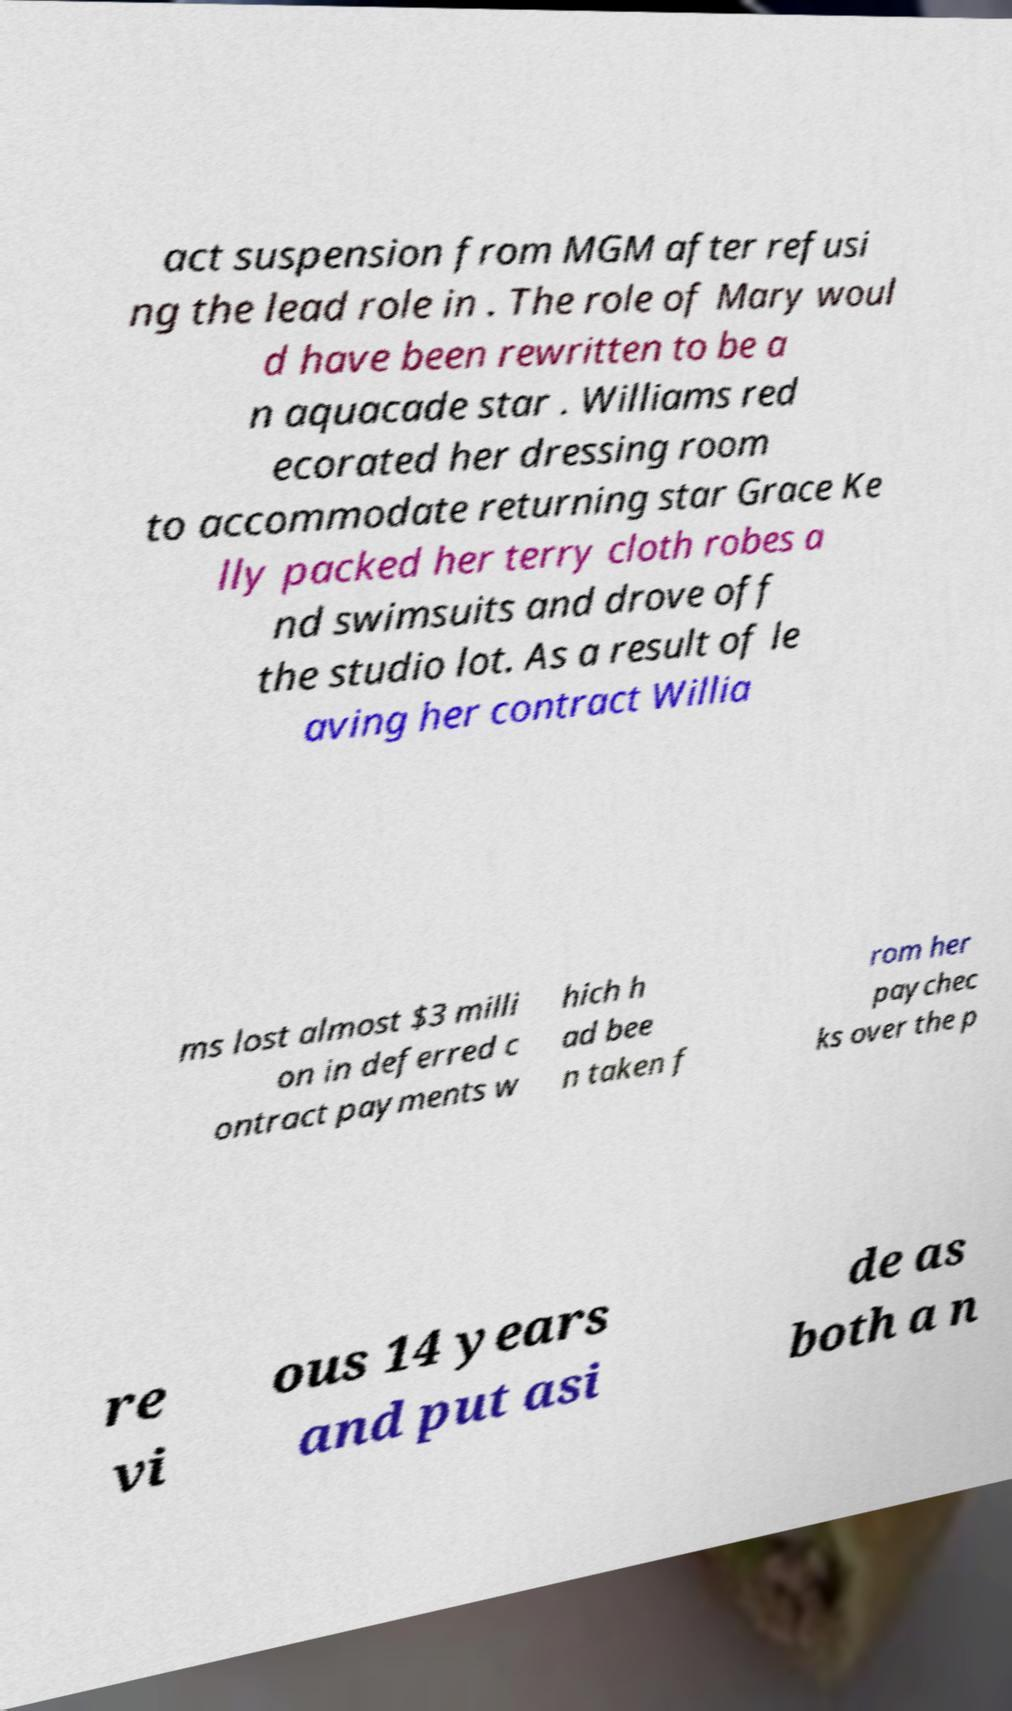Could you assist in decoding the text presented in this image and type it out clearly? act suspension from MGM after refusi ng the lead role in . The role of Mary woul d have been rewritten to be a n aquacade star . Williams red ecorated her dressing room to accommodate returning star Grace Ke lly packed her terry cloth robes a nd swimsuits and drove off the studio lot. As a result of le aving her contract Willia ms lost almost $3 milli on in deferred c ontract payments w hich h ad bee n taken f rom her paychec ks over the p re vi ous 14 years and put asi de as both a n 